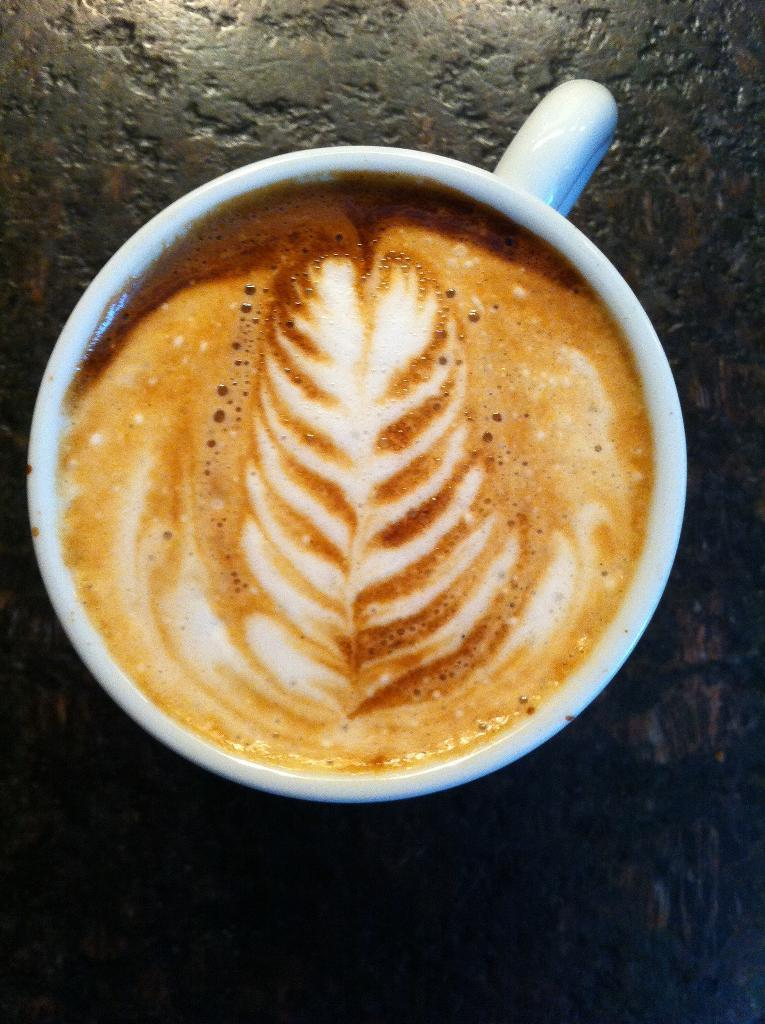What is in the cup that is visible in the image? The cup contains coffee. Where is the cup located in the image? The cup is placed on a platform. What type of secretary can be seen working in the image? There is no secretary present in the image; it only features a cup of coffee on a platform. 